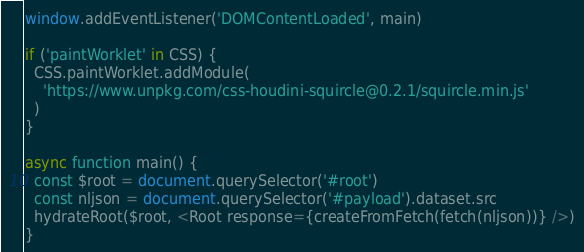<code> <loc_0><loc_0><loc_500><loc_500><_JavaScript_>
window.addEventListener('DOMContentLoaded', main)

if ('paintWorklet' in CSS) {
  CSS.paintWorklet.addModule(
    'https://www.unpkg.com/css-houdini-squircle@0.2.1/squircle.min.js'
  )
}

async function main() {
  const $root = document.querySelector('#root')
  const nljson = document.querySelector('#payload').dataset.src
  hydrateRoot($root, <Root response={createFromFetch(fetch(nljson))} />)
}
</code> 